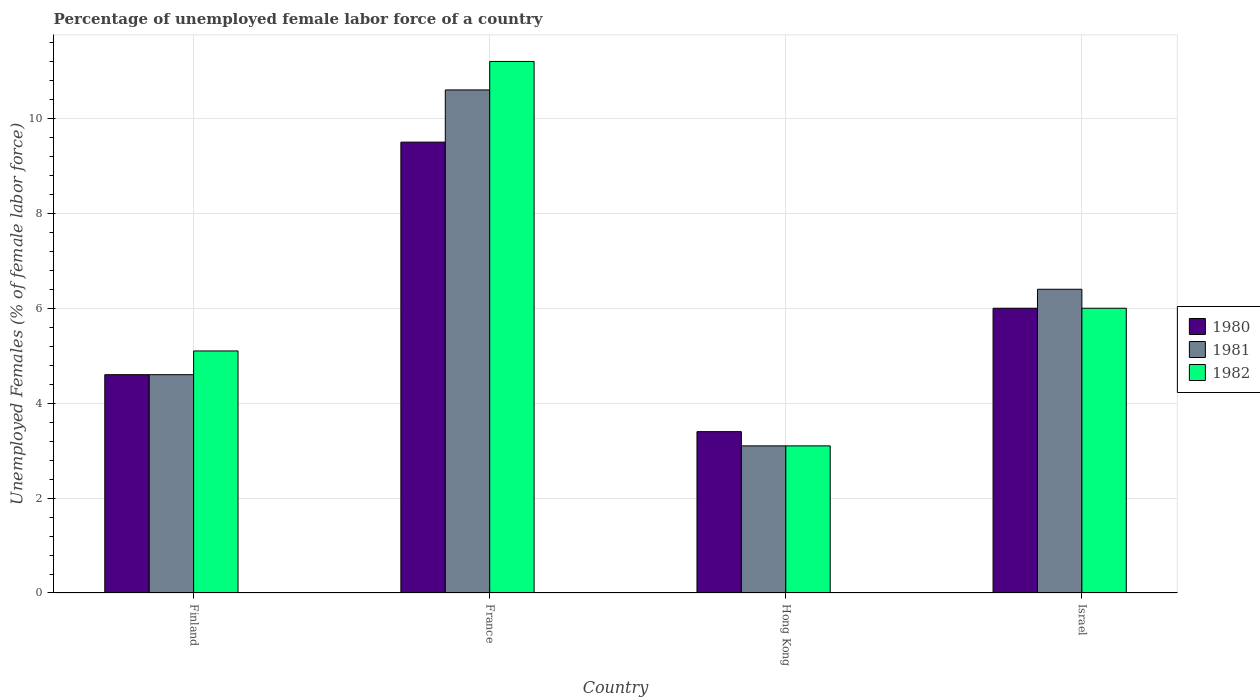How many bars are there on the 3rd tick from the left?
Ensure brevity in your answer.  3. How many bars are there on the 3rd tick from the right?
Provide a short and direct response. 3. What is the label of the 2nd group of bars from the left?
Provide a succinct answer. France. What is the percentage of unemployed female labor force in 1980 in Finland?
Offer a terse response. 4.6. Across all countries, what is the maximum percentage of unemployed female labor force in 1981?
Give a very brief answer. 10.6. Across all countries, what is the minimum percentage of unemployed female labor force in 1981?
Your answer should be very brief. 3.1. In which country was the percentage of unemployed female labor force in 1980 maximum?
Your response must be concise. France. In which country was the percentage of unemployed female labor force in 1980 minimum?
Make the answer very short. Hong Kong. What is the total percentage of unemployed female labor force in 1982 in the graph?
Your response must be concise. 25.4. What is the difference between the percentage of unemployed female labor force in 1981 in Finland and that in France?
Offer a terse response. -6. What is the difference between the percentage of unemployed female labor force in 1980 in France and the percentage of unemployed female labor force in 1981 in Israel?
Offer a terse response. 3.1. What is the average percentage of unemployed female labor force in 1980 per country?
Offer a very short reply. 5.88. In how many countries, is the percentage of unemployed female labor force in 1982 greater than 6 %?
Offer a very short reply. 1. What is the ratio of the percentage of unemployed female labor force in 1981 in Finland to that in Hong Kong?
Offer a terse response. 1.48. Is the percentage of unemployed female labor force in 1982 in France less than that in Israel?
Your answer should be very brief. No. Is the difference between the percentage of unemployed female labor force in 1982 in France and Hong Kong greater than the difference between the percentage of unemployed female labor force in 1980 in France and Hong Kong?
Give a very brief answer. Yes. What is the difference between the highest and the second highest percentage of unemployed female labor force in 1981?
Your response must be concise. 6. What is the difference between the highest and the lowest percentage of unemployed female labor force in 1981?
Your response must be concise. 7.5. In how many countries, is the percentage of unemployed female labor force in 1982 greater than the average percentage of unemployed female labor force in 1982 taken over all countries?
Provide a short and direct response. 1. What does the 3rd bar from the right in Hong Kong represents?
Offer a very short reply. 1980. Is it the case that in every country, the sum of the percentage of unemployed female labor force in 1980 and percentage of unemployed female labor force in 1981 is greater than the percentage of unemployed female labor force in 1982?
Make the answer very short. Yes. Are all the bars in the graph horizontal?
Provide a short and direct response. No. What is the difference between two consecutive major ticks on the Y-axis?
Offer a very short reply. 2. Does the graph contain any zero values?
Ensure brevity in your answer.  No. Does the graph contain grids?
Provide a short and direct response. Yes. Where does the legend appear in the graph?
Provide a short and direct response. Center right. How many legend labels are there?
Your answer should be compact. 3. How are the legend labels stacked?
Keep it short and to the point. Vertical. What is the title of the graph?
Offer a terse response. Percentage of unemployed female labor force of a country. What is the label or title of the X-axis?
Make the answer very short. Country. What is the label or title of the Y-axis?
Ensure brevity in your answer.  Unemployed Females (% of female labor force). What is the Unemployed Females (% of female labor force) in 1980 in Finland?
Your answer should be compact. 4.6. What is the Unemployed Females (% of female labor force) in 1981 in Finland?
Provide a succinct answer. 4.6. What is the Unemployed Females (% of female labor force) in 1982 in Finland?
Provide a short and direct response. 5.1. What is the Unemployed Females (% of female labor force) of 1980 in France?
Provide a short and direct response. 9.5. What is the Unemployed Females (% of female labor force) of 1981 in France?
Your answer should be very brief. 10.6. What is the Unemployed Females (% of female labor force) in 1982 in France?
Offer a terse response. 11.2. What is the Unemployed Females (% of female labor force) of 1980 in Hong Kong?
Your answer should be very brief. 3.4. What is the Unemployed Females (% of female labor force) in 1981 in Hong Kong?
Your response must be concise. 3.1. What is the Unemployed Females (% of female labor force) of 1982 in Hong Kong?
Ensure brevity in your answer.  3.1. What is the Unemployed Females (% of female labor force) of 1981 in Israel?
Ensure brevity in your answer.  6.4. What is the Unemployed Females (% of female labor force) of 1982 in Israel?
Offer a terse response. 6. Across all countries, what is the maximum Unemployed Females (% of female labor force) in 1980?
Give a very brief answer. 9.5. Across all countries, what is the maximum Unemployed Females (% of female labor force) of 1981?
Give a very brief answer. 10.6. Across all countries, what is the maximum Unemployed Females (% of female labor force) of 1982?
Give a very brief answer. 11.2. Across all countries, what is the minimum Unemployed Females (% of female labor force) of 1980?
Ensure brevity in your answer.  3.4. Across all countries, what is the minimum Unemployed Females (% of female labor force) of 1981?
Your response must be concise. 3.1. Across all countries, what is the minimum Unemployed Females (% of female labor force) of 1982?
Your response must be concise. 3.1. What is the total Unemployed Females (% of female labor force) in 1980 in the graph?
Your answer should be very brief. 23.5. What is the total Unemployed Females (% of female labor force) of 1981 in the graph?
Offer a terse response. 24.7. What is the total Unemployed Females (% of female labor force) of 1982 in the graph?
Make the answer very short. 25.4. What is the difference between the Unemployed Females (% of female labor force) in 1980 in Finland and that in France?
Make the answer very short. -4.9. What is the difference between the Unemployed Females (% of female labor force) in 1982 in Finland and that in France?
Give a very brief answer. -6.1. What is the difference between the Unemployed Females (% of female labor force) of 1980 in Finland and that in Israel?
Ensure brevity in your answer.  -1.4. What is the difference between the Unemployed Females (% of female labor force) of 1981 in Finland and that in Israel?
Offer a terse response. -1.8. What is the difference between the Unemployed Females (% of female labor force) in 1982 in France and that in Hong Kong?
Ensure brevity in your answer.  8.1. What is the difference between the Unemployed Females (% of female labor force) of 1980 in France and that in Israel?
Ensure brevity in your answer.  3.5. What is the difference between the Unemployed Females (% of female labor force) in 1981 in France and that in Israel?
Provide a succinct answer. 4.2. What is the difference between the Unemployed Females (% of female labor force) of 1982 in France and that in Israel?
Your answer should be compact. 5.2. What is the difference between the Unemployed Females (% of female labor force) of 1980 in Hong Kong and that in Israel?
Your response must be concise. -2.6. What is the difference between the Unemployed Females (% of female labor force) of 1981 in Hong Kong and that in Israel?
Provide a short and direct response. -3.3. What is the difference between the Unemployed Females (% of female labor force) of 1980 in Finland and the Unemployed Females (% of female labor force) of 1982 in France?
Your answer should be compact. -6.6. What is the difference between the Unemployed Females (% of female labor force) in 1981 in Finland and the Unemployed Females (% of female labor force) in 1982 in France?
Your response must be concise. -6.6. What is the difference between the Unemployed Females (% of female labor force) of 1980 in Finland and the Unemployed Females (% of female labor force) of 1982 in Hong Kong?
Your answer should be very brief. 1.5. What is the difference between the Unemployed Females (% of female labor force) in 1981 in Finland and the Unemployed Females (% of female labor force) in 1982 in Hong Kong?
Your response must be concise. 1.5. What is the difference between the Unemployed Females (% of female labor force) in 1980 in Finland and the Unemployed Females (% of female labor force) in 1982 in Israel?
Your response must be concise. -1.4. What is the difference between the Unemployed Females (% of female labor force) of 1981 in Finland and the Unemployed Females (% of female labor force) of 1982 in Israel?
Provide a succinct answer. -1.4. What is the difference between the Unemployed Females (% of female labor force) of 1980 in France and the Unemployed Females (% of female labor force) of 1981 in Hong Kong?
Provide a short and direct response. 6.4. What is the difference between the Unemployed Females (% of female labor force) in 1981 in France and the Unemployed Females (% of female labor force) in 1982 in Hong Kong?
Provide a short and direct response. 7.5. What is the difference between the Unemployed Females (% of female labor force) of 1980 in France and the Unemployed Females (% of female labor force) of 1982 in Israel?
Offer a terse response. 3.5. What is the difference between the Unemployed Females (% of female labor force) in 1981 in France and the Unemployed Females (% of female labor force) in 1982 in Israel?
Make the answer very short. 4.6. What is the difference between the Unemployed Females (% of female labor force) in 1980 in Hong Kong and the Unemployed Females (% of female labor force) in 1981 in Israel?
Give a very brief answer. -3. What is the difference between the Unemployed Females (% of female labor force) in 1981 in Hong Kong and the Unemployed Females (% of female labor force) in 1982 in Israel?
Provide a short and direct response. -2.9. What is the average Unemployed Females (% of female labor force) of 1980 per country?
Provide a short and direct response. 5.88. What is the average Unemployed Females (% of female labor force) in 1981 per country?
Give a very brief answer. 6.17. What is the average Unemployed Females (% of female labor force) in 1982 per country?
Your response must be concise. 6.35. What is the difference between the Unemployed Females (% of female labor force) in 1980 and Unemployed Females (% of female labor force) in 1981 in Finland?
Your answer should be compact. 0. What is the difference between the Unemployed Females (% of female labor force) of 1980 and Unemployed Females (% of female labor force) of 1982 in Finland?
Your response must be concise. -0.5. What is the difference between the Unemployed Females (% of female labor force) in 1981 and Unemployed Females (% of female labor force) in 1982 in France?
Make the answer very short. -0.6. What is the difference between the Unemployed Females (% of female labor force) of 1980 and Unemployed Females (% of female labor force) of 1982 in Hong Kong?
Your answer should be compact. 0.3. What is the difference between the Unemployed Females (% of female labor force) of 1981 and Unemployed Females (% of female labor force) of 1982 in Hong Kong?
Offer a very short reply. 0. What is the difference between the Unemployed Females (% of female labor force) of 1980 and Unemployed Females (% of female labor force) of 1981 in Israel?
Your answer should be compact. -0.4. What is the difference between the Unemployed Females (% of female labor force) in 1980 and Unemployed Females (% of female labor force) in 1982 in Israel?
Your response must be concise. 0. What is the difference between the Unemployed Females (% of female labor force) in 1981 and Unemployed Females (% of female labor force) in 1982 in Israel?
Your answer should be compact. 0.4. What is the ratio of the Unemployed Females (% of female labor force) of 1980 in Finland to that in France?
Your answer should be very brief. 0.48. What is the ratio of the Unemployed Females (% of female labor force) of 1981 in Finland to that in France?
Offer a very short reply. 0.43. What is the ratio of the Unemployed Females (% of female labor force) of 1982 in Finland to that in France?
Provide a succinct answer. 0.46. What is the ratio of the Unemployed Females (% of female labor force) of 1980 in Finland to that in Hong Kong?
Provide a succinct answer. 1.35. What is the ratio of the Unemployed Females (% of female labor force) of 1981 in Finland to that in Hong Kong?
Ensure brevity in your answer.  1.48. What is the ratio of the Unemployed Females (% of female labor force) of 1982 in Finland to that in Hong Kong?
Offer a terse response. 1.65. What is the ratio of the Unemployed Females (% of female labor force) in 1980 in Finland to that in Israel?
Make the answer very short. 0.77. What is the ratio of the Unemployed Females (% of female labor force) of 1981 in Finland to that in Israel?
Keep it short and to the point. 0.72. What is the ratio of the Unemployed Females (% of female labor force) in 1982 in Finland to that in Israel?
Provide a short and direct response. 0.85. What is the ratio of the Unemployed Females (% of female labor force) in 1980 in France to that in Hong Kong?
Offer a very short reply. 2.79. What is the ratio of the Unemployed Females (% of female labor force) in 1981 in France to that in Hong Kong?
Provide a succinct answer. 3.42. What is the ratio of the Unemployed Females (% of female labor force) of 1982 in France to that in Hong Kong?
Give a very brief answer. 3.61. What is the ratio of the Unemployed Females (% of female labor force) of 1980 in France to that in Israel?
Your answer should be compact. 1.58. What is the ratio of the Unemployed Females (% of female labor force) in 1981 in France to that in Israel?
Your response must be concise. 1.66. What is the ratio of the Unemployed Females (% of female labor force) of 1982 in France to that in Israel?
Provide a succinct answer. 1.87. What is the ratio of the Unemployed Females (% of female labor force) in 1980 in Hong Kong to that in Israel?
Offer a terse response. 0.57. What is the ratio of the Unemployed Females (% of female labor force) of 1981 in Hong Kong to that in Israel?
Keep it short and to the point. 0.48. What is the ratio of the Unemployed Females (% of female labor force) of 1982 in Hong Kong to that in Israel?
Keep it short and to the point. 0.52. What is the difference between the highest and the second highest Unemployed Females (% of female labor force) of 1980?
Provide a short and direct response. 3.5. What is the difference between the highest and the second highest Unemployed Females (% of female labor force) in 1981?
Provide a short and direct response. 4.2. What is the difference between the highest and the second highest Unemployed Females (% of female labor force) in 1982?
Ensure brevity in your answer.  5.2. What is the difference between the highest and the lowest Unemployed Females (% of female labor force) in 1982?
Your answer should be compact. 8.1. 